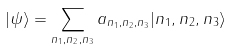Convert formula to latex. <formula><loc_0><loc_0><loc_500><loc_500>| \psi \rangle = \sum _ { n _ { 1 } , n _ { 2 } , n _ { 3 } } a _ { n _ { 1 } , n _ { 2 } , n _ { 3 } } | n _ { 1 } , n _ { 2 } , n _ { 3 } \rangle</formula> 